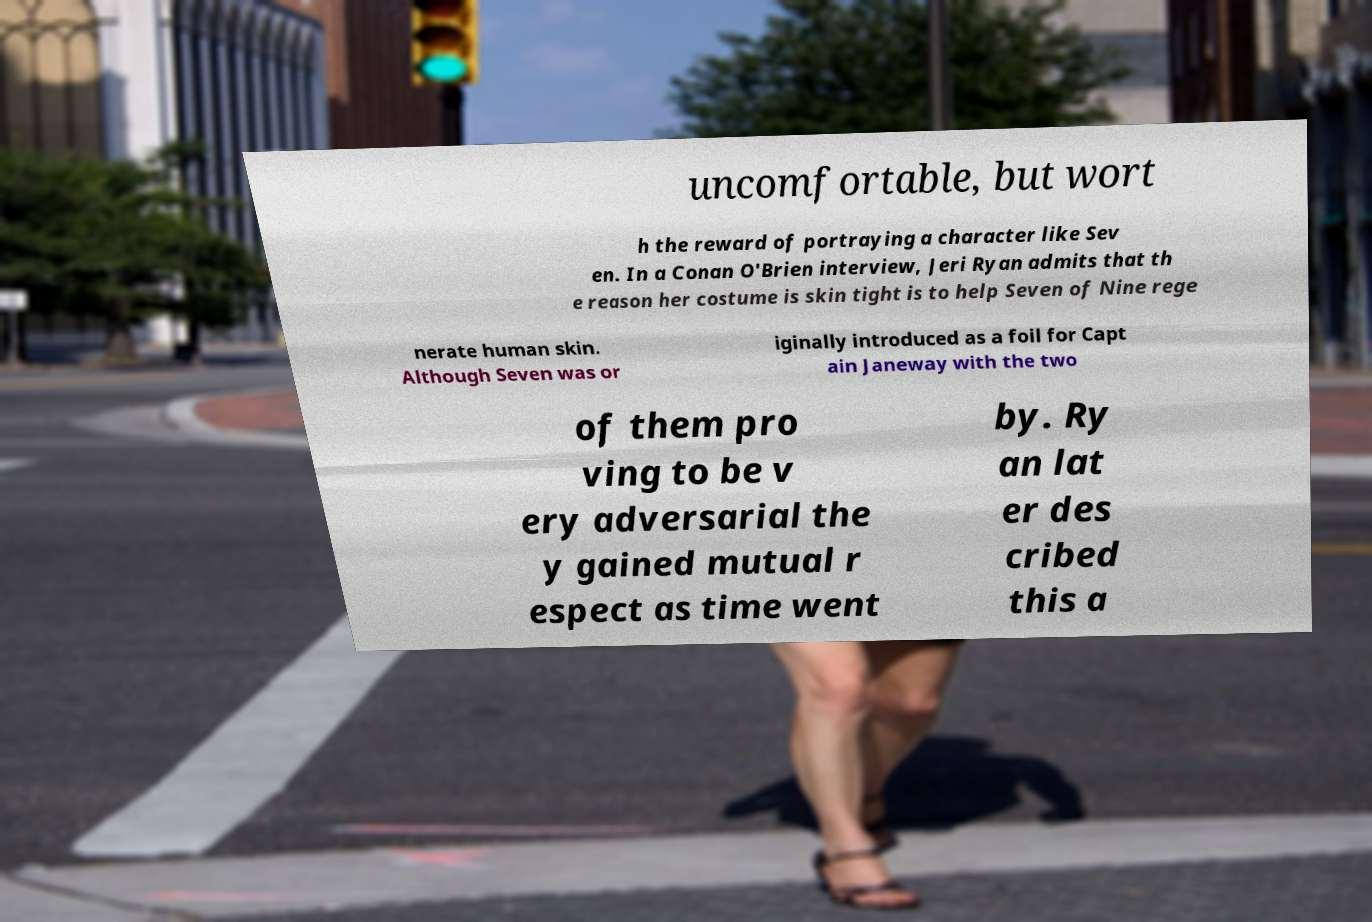Can you read and provide the text displayed in the image?This photo seems to have some interesting text. Can you extract and type it out for me? uncomfortable, but wort h the reward of portraying a character like Sev en. In a Conan O'Brien interview, Jeri Ryan admits that th e reason her costume is skin tight is to help Seven of Nine rege nerate human skin. Although Seven was or iginally introduced as a foil for Capt ain Janeway with the two of them pro ving to be v ery adversarial the y gained mutual r espect as time went by. Ry an lat er des cribed this a 